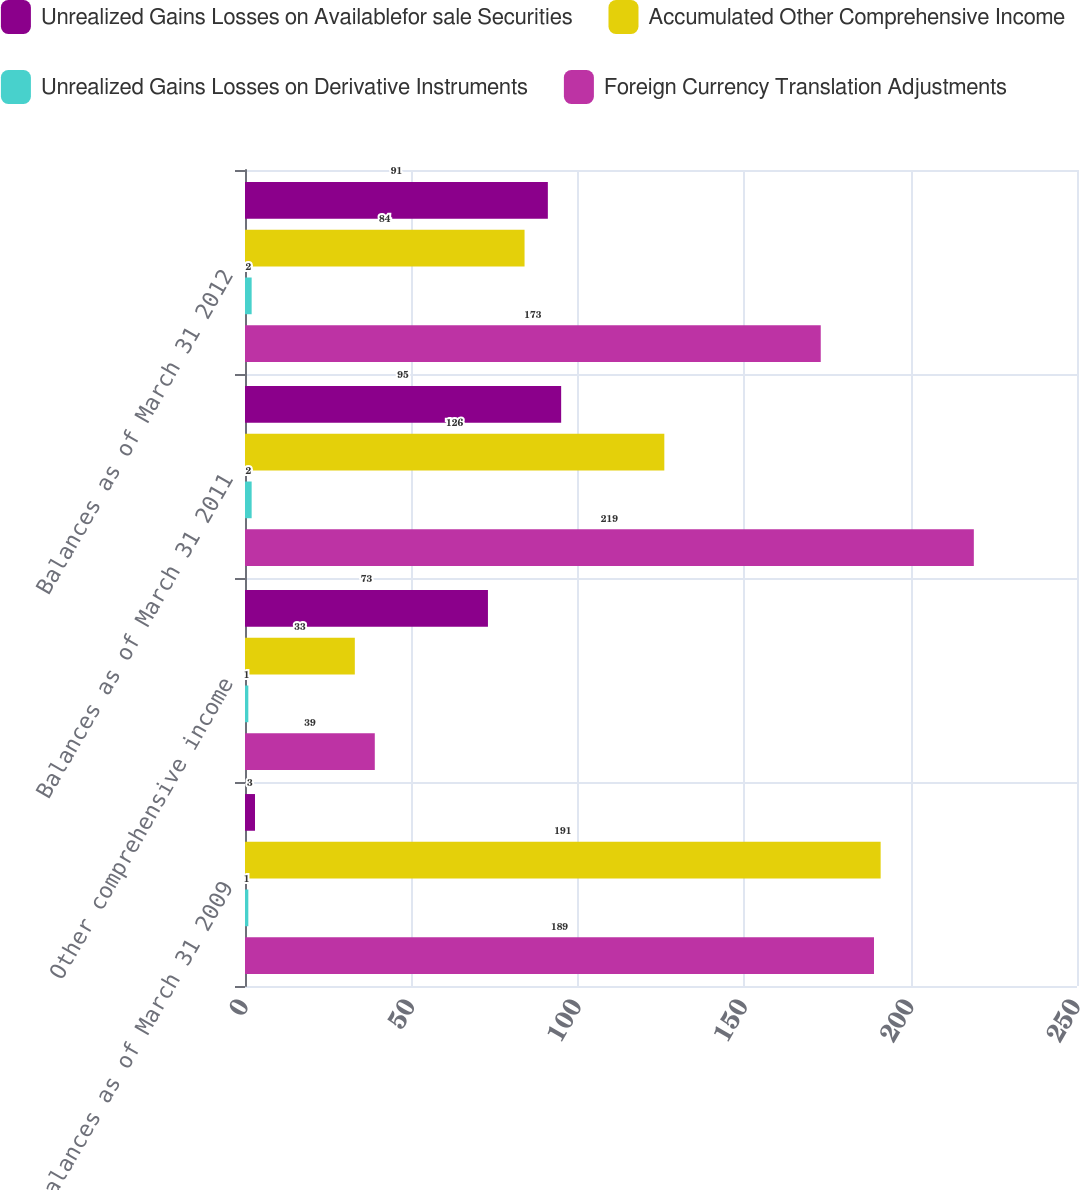Convert chart. <chart><loc_0><loc_0><loc_500><loc_500><stacked_bar_chart><ecel><fcel>Balances as of March 31 2009<fcel>Other comprehensive income<fcel>Balances as of March 31 2011<fcel>Balances as of March 31 2012<nl><fcel>Unrealized Gains Losses on Availablefor sale Securities<fcel>3<fcel>73<fcel>95<fcel>91<nl><fcel>Accumulated Other Comprehensive Income<fcel>191<fcel>33<fcel>126<fcel>84<nl><fcel>Unrealized Gains Losses on Derivative Instruments<fcel>1<fcel>1<fcel>2<fcel>2<nl><fcel>Foreign Currency Translation Adjustments<fcel>189<fcel>39<fcel>219<fcel>173<nl></chart> 